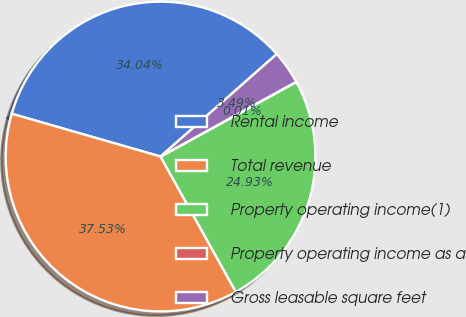Convert chart. <chart><loc_0><loc_0><loc_500><loc_500><pie_chart><fcel>Rental income<fcel>Total revenue<fcel>Property operating income(1)<fcel>Property operating income as a<fcel>Gross leasable square feet<nl><fcel>34.04%<fcel>37.53%<fcel>24.93%<fcel>0.01%<fcel>3.49%<nl></chart> 